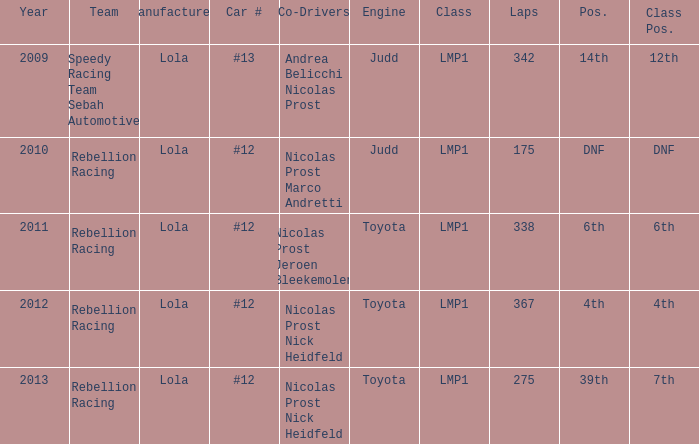What is Class Pos., when Year is before 2013, and when Laps is greater than 175? 12th, 6th, 4th. 